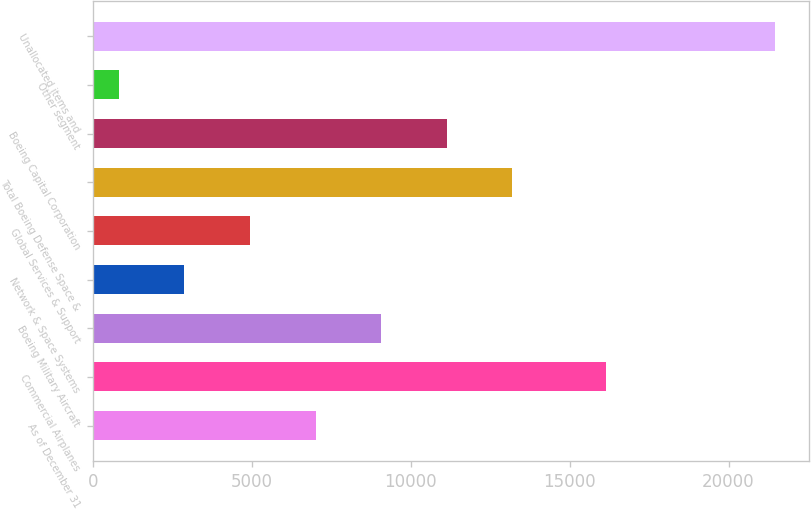Convert chart. <chart><loc_0><loc_0><loc_500><loc_500><bar_chart><fcel>As of December 31<fcel>Commercial Airplanes<fcel>Boeing Military Aircraft<fcel>Network & Space Systems<fcel>Global Services & Support<fcel>Total Boeing Defense Space &<fcel>Boeing Capital Corporation<fcel>Other segment<fcel>Unallocated items and<nl><fcel>7005.3<fcel>16132<fcel>9070.4<fcel>2875.1<fcel>4940.2<fcel>13200.6<fcel>11135.5<fcel>810<fcel>21461<nl></chart> 